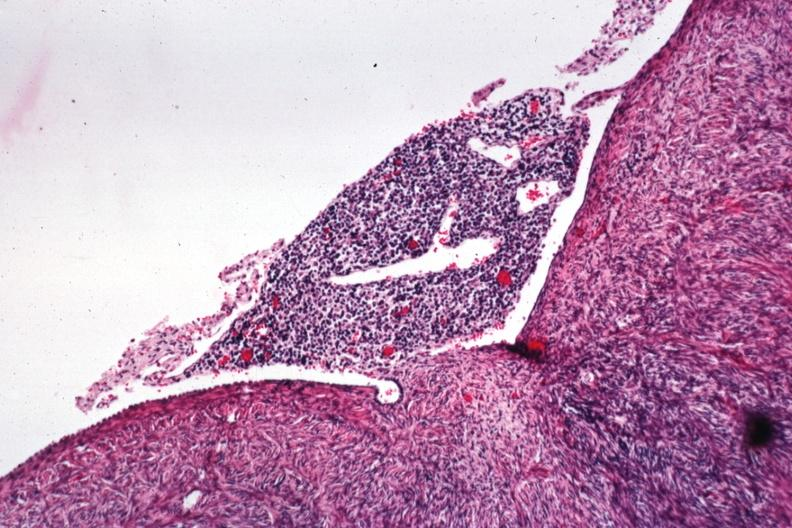what is present?
Answer the question using a single word or phrase. Female reproductive 